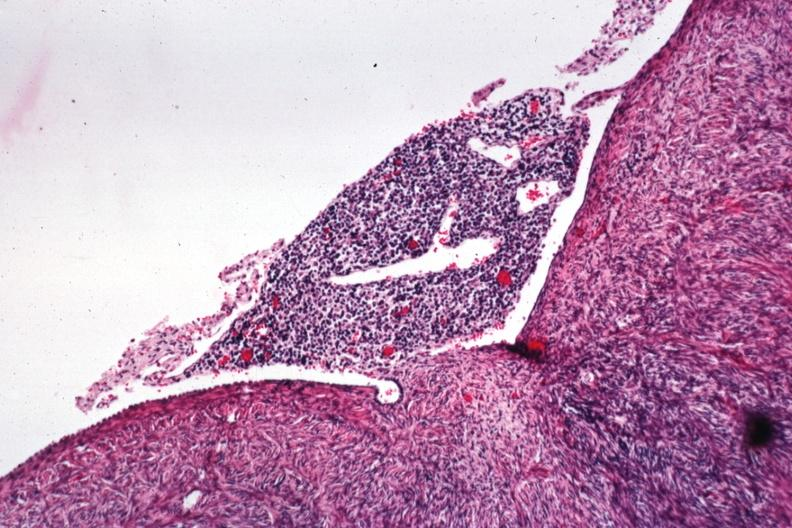what is present?
Answer the question using a single word or phrase. Female reproductive 